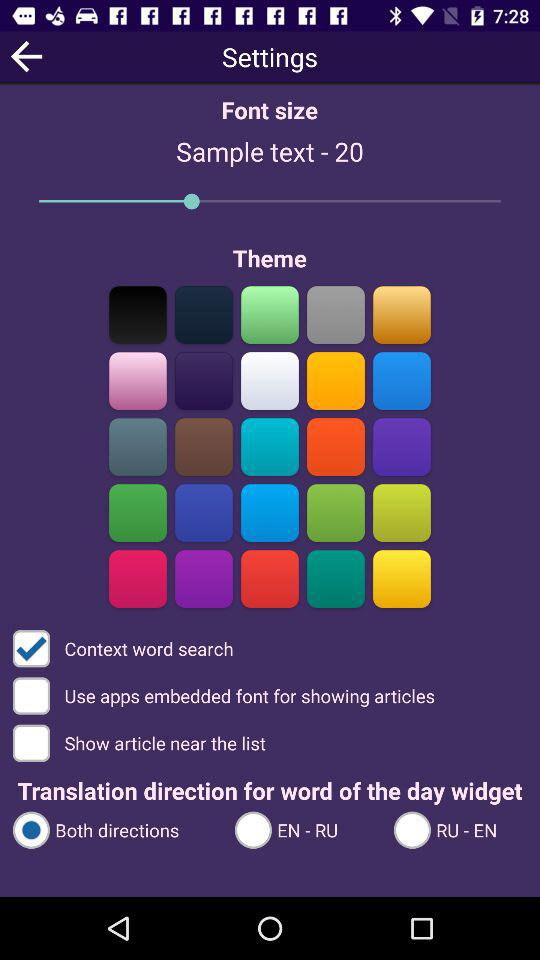What is the font size? The font size is 20. 